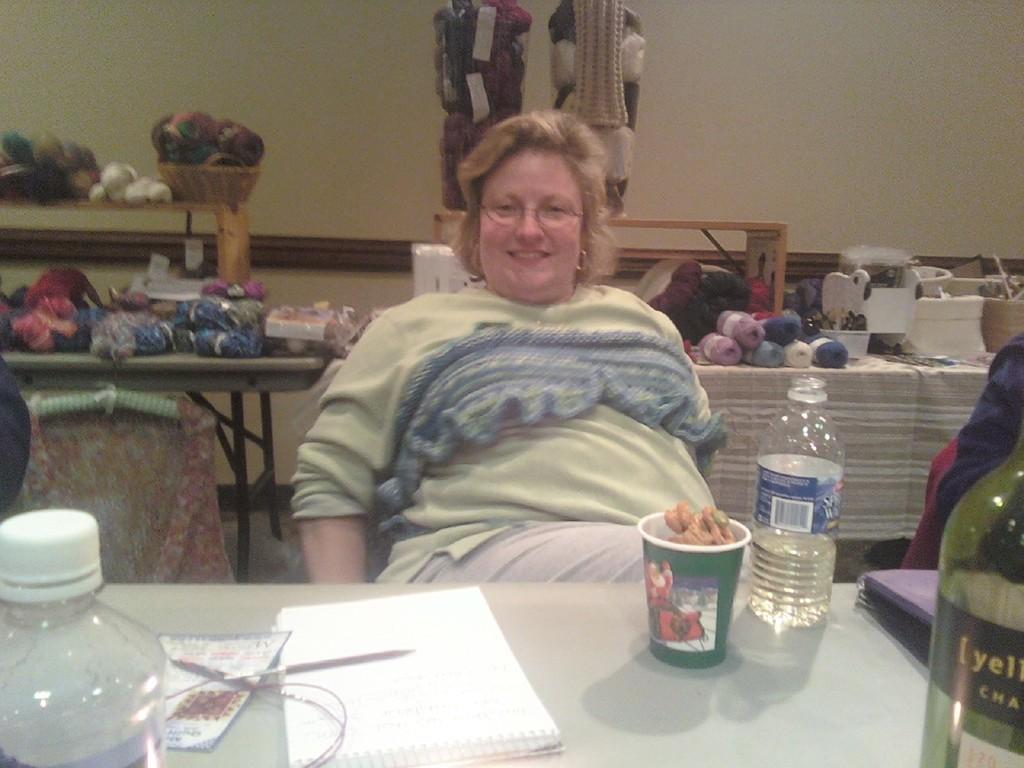What is the person in the image doing? The person is sitting on a chair in the image. What objects are on the table in the image? There are bottles, a box, a book, and a pen on the table in the image. Can you describe any other objects on the table? There are other things on the table, but their specific details are not mentioned in the provided facts. What can be seen in the background of the image? There is a wall in the background of the image. How many horses are present in the image? There are no horses present in the image. What is the person's interest in the image? The provided facts do not mention the person's interest, so it cannot be determined from the image. 